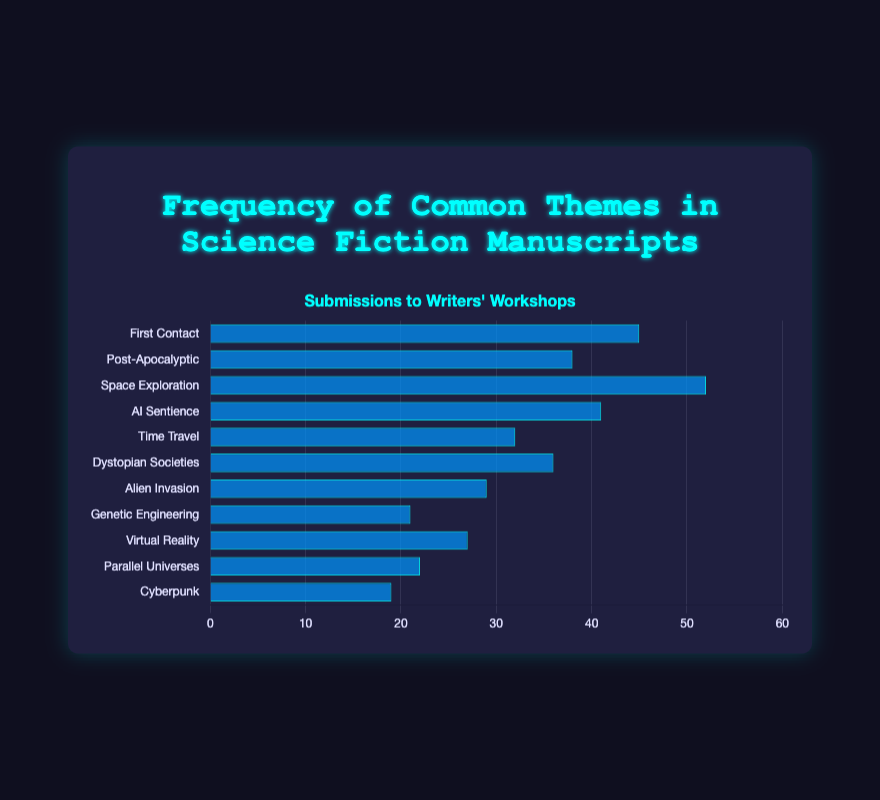Which theme appears most frequently in the manuscripts? By looking at the bar heights, the bar representing "Space Exploration" is the tallest, indicating it has the highest frequency.
Answer: Space Exploration Which two themes have the closest frequencies? By comparing the bar heights of all themes, "Post-Apocalyptic" and "Dystopian Societies" have very similar bar heights.
Answer: Post-Apocalyptic and Dystopian Societies What is the total frequency of "AI Sentience" and "Time Travel"? To find the total frequency, add the frequencies of "AI Sentience" (41) and "Time Travel" (32): 41 + 32 = 73.
Answer: 73 How much more frequent is "First Contact" compared to "Alien Invasion"? Subtract the frequency of "Alien Invasion" (29) from "First Contact" (45): 45 - 29 = 16.
Answer: 16 What is the average frequency of "Cyberpunk", "Virtual Reality", and "Genetic Engineering"? Add the frequencies of "Cyberpunk" (19), "Virtual Reality" (27), and "Genetic Engineering" (21), then divide by 3: (19 + 27 + 21) / 3 = 67 / 3 = ~22.33.
Answer: ~22.33 Does "Virtual Reality" have a higher or lower frequency than "Time Travel"? Comparing the bar heights, "Time Travel" (32) is higher than "Virtual Reality" (27).
Answer: Lower How many themes have frequencies above 30? Count the bars that exceed a height corresponding to a frequency of 30: "First Contact", "Post-Apocalyptic", "Space Exploration", "AI Sentience", "Time Travel", "Dystopian Societies". There are 6 such themes.
Answer: 6 What is the difference in frequency between the most and least common themes? Subtract the frequency of the least common theme "Cyberpunk" (19) from the most common theme "Space Exploration" (52): 52 - 19 = 33.
Answer: 33 Which theme is the least common in the manuscripts? The shortest bar in the chart represents "Cyberpunk", indicating it has the lowest frequency.
Answer: Cyberpunk 